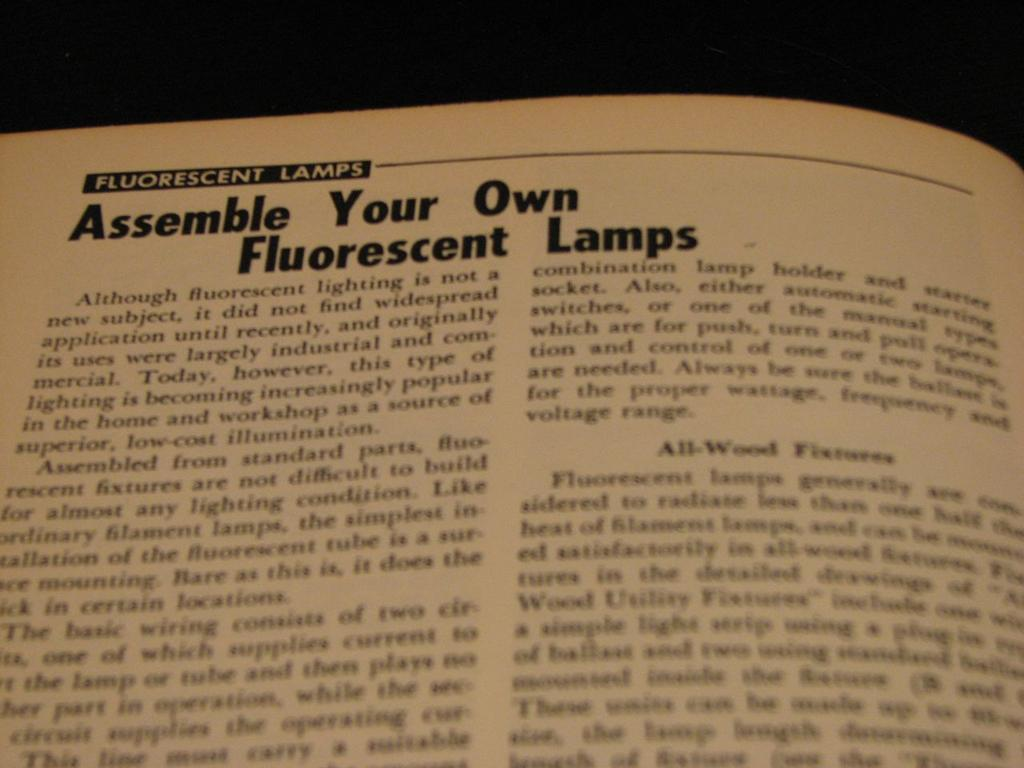<image>
Describe the image concisely. A page in a book showing an article about florescent lamps. 